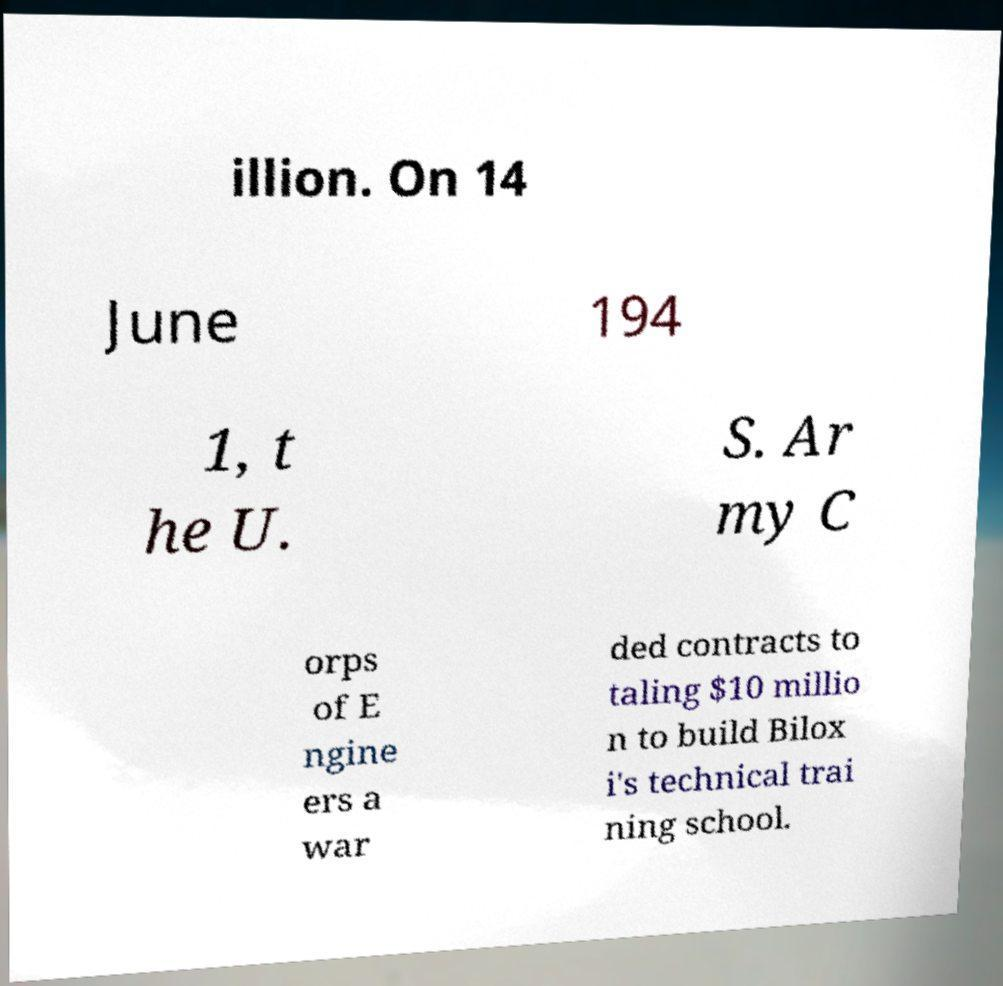I need the written content from this picture converted into text. Can you do that? illion. On 14 June 194 1, t he U. S. Ar my C orps of E ngine ers a war ded contracts to taling $10 millio n to build Bilox i's technical trai ning school. 